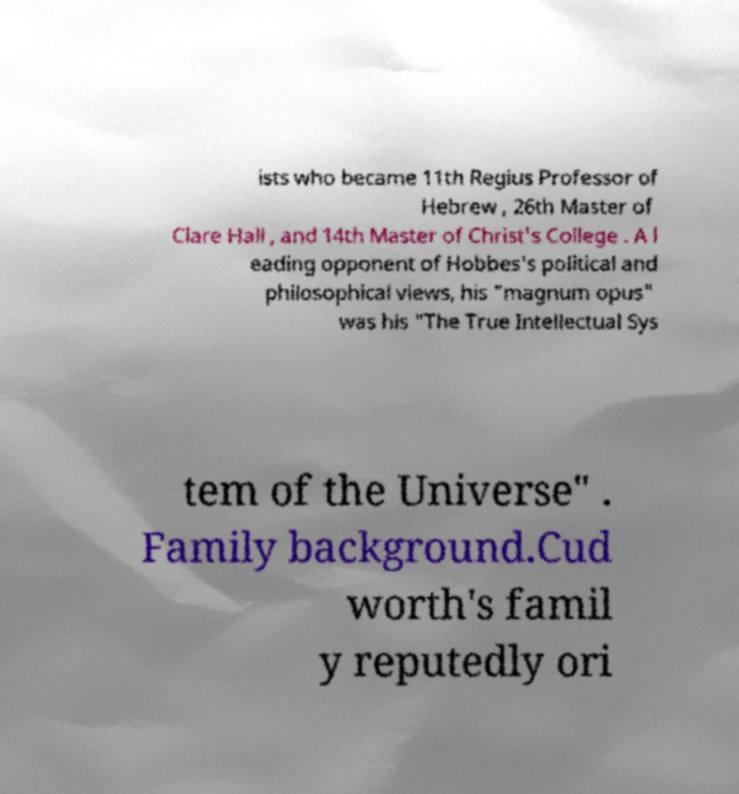Could you assist in decoding the text presented in this image and type it out clearly? ists who became 11th Regius Professor of Hebrew , 26th Master of Clare Hall , and 14th Master of Christ's College . A l eading opponent of Hobbes's political and philosophical views, his "magnum opus" was his "The True Intellectual Sys tem of the Universe" . Family background.Cud worth's famil y reputedly ori 